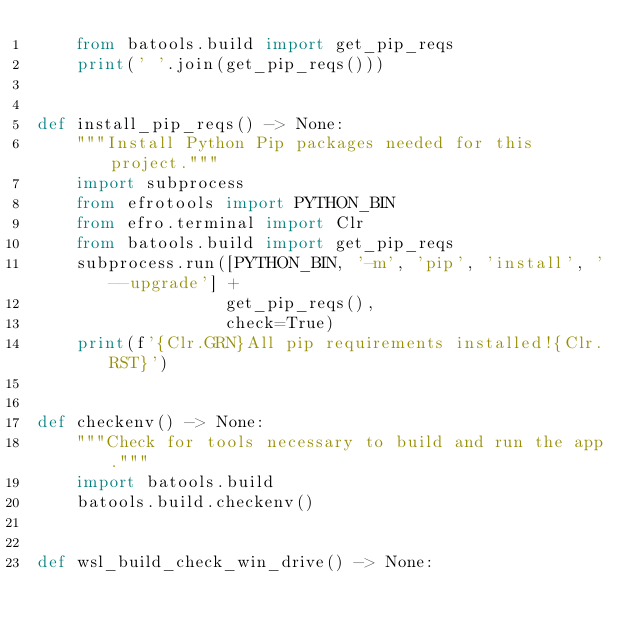<code> <loc_0><loc_0><loc_500><loc_500><_Python_>    from batools.build import get_pip_reqs
    print(' '.join(get_pip_reqs()))


def install_pip_reqs() -> None:
    """Install Python Pip packages needed for this project."""
    import subprocess
    from efrotools import PYTHON_BIN
    from efro.terminal import Clr
    from batools.build import get_pip_reqs
    subprocess.run([PYTHON_BIN, '-m', 'pip', 'install', '--upgrade'] +
                   get_pip_reqs(),
                   check=True)
    print(f'{Clr.GRN}All pip requirements installed!{Clr.RST}')


def checkenv() -> None:
    """Check for tools necessary to build and run the app."""
    import batools.build
    batools.build.checkenv()


def wsl_build_check_win_drive() -> None:</code> 